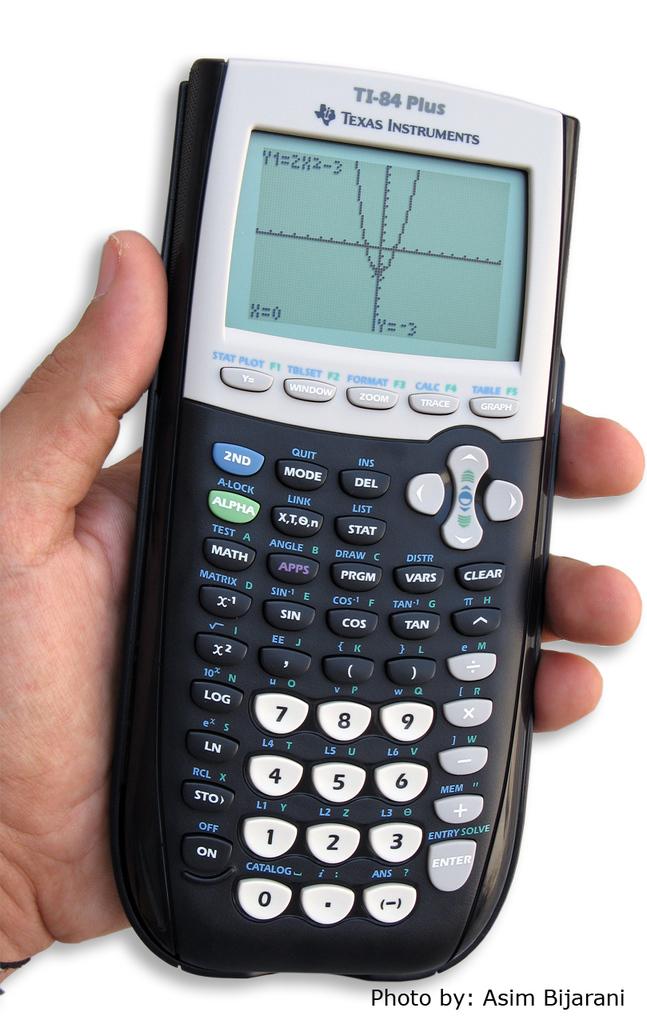What type of calculator is this?
Offer a terse response. Texas instruments. Who is this photo by?
Ensure brevity in your answer.  Asim bijarani. 